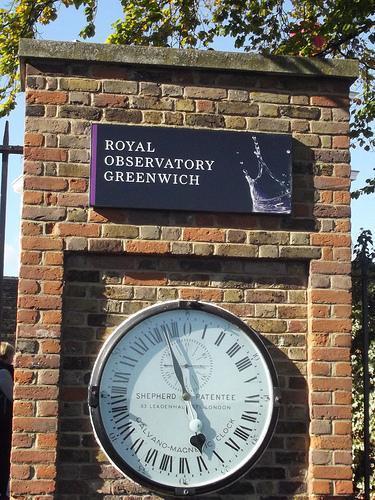How many clocks are there?
Give a very brief answer. 1. 